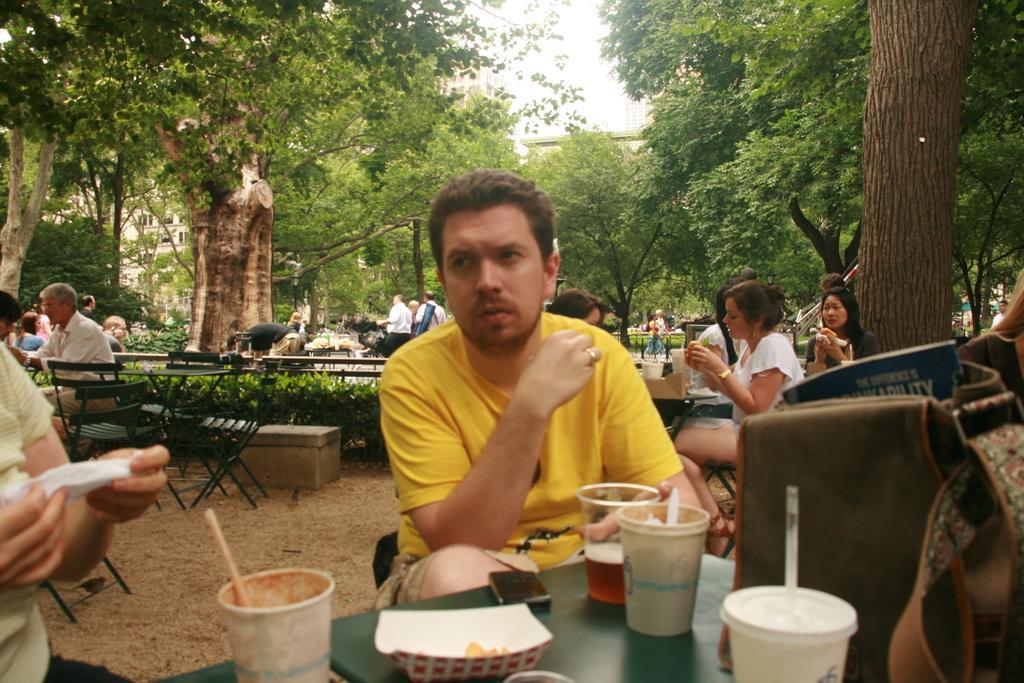Can you describe this image briefly? Few persons are sitting on the chairs and few persons are standing,this person holding tissue. We can see cups,glass,mobile and bag on the table. We can see trees,plant. A far we can see building. 